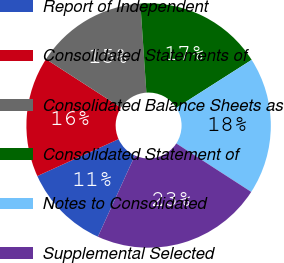Convert chart to OTSL. <chart><loc_0><loc_0><loc_500><loc_500><pie_chart><fcel>Report of Independent<fcel>Consolidated Statements of<fcel>Consolidated Balance Sheets as<fcel>Consolidated Statement of<fcel>Notes to Consolidated<fcel>Supplemental Selected<nl><fcel>11.41%<fcel>15.92%<fcel>14.79%<fcel>17.04%<fcel>18.17%<fcel>22.67%<nl></chart> 